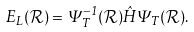<formula> <loc_0><loc_0><loc_500><loc_500>E _ { L } ( \mathcal { R } ) = \Psi _ { T } ^ { - 1 } ( \mathcal { R } ) \hat { H } \Psi _ { T } ( \mathcal { R } ) .</formula> 